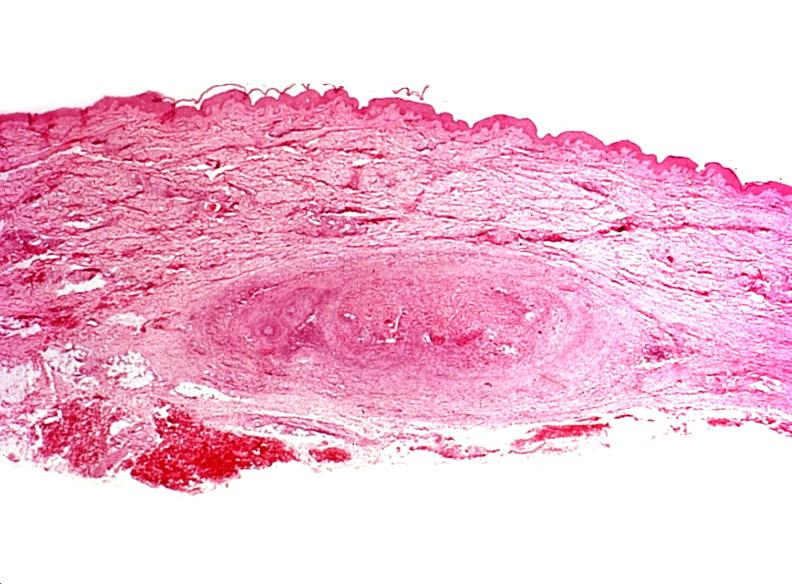does this image show migratory thrombophlebitis?
Answer the question using a single word or phrase. Yes 